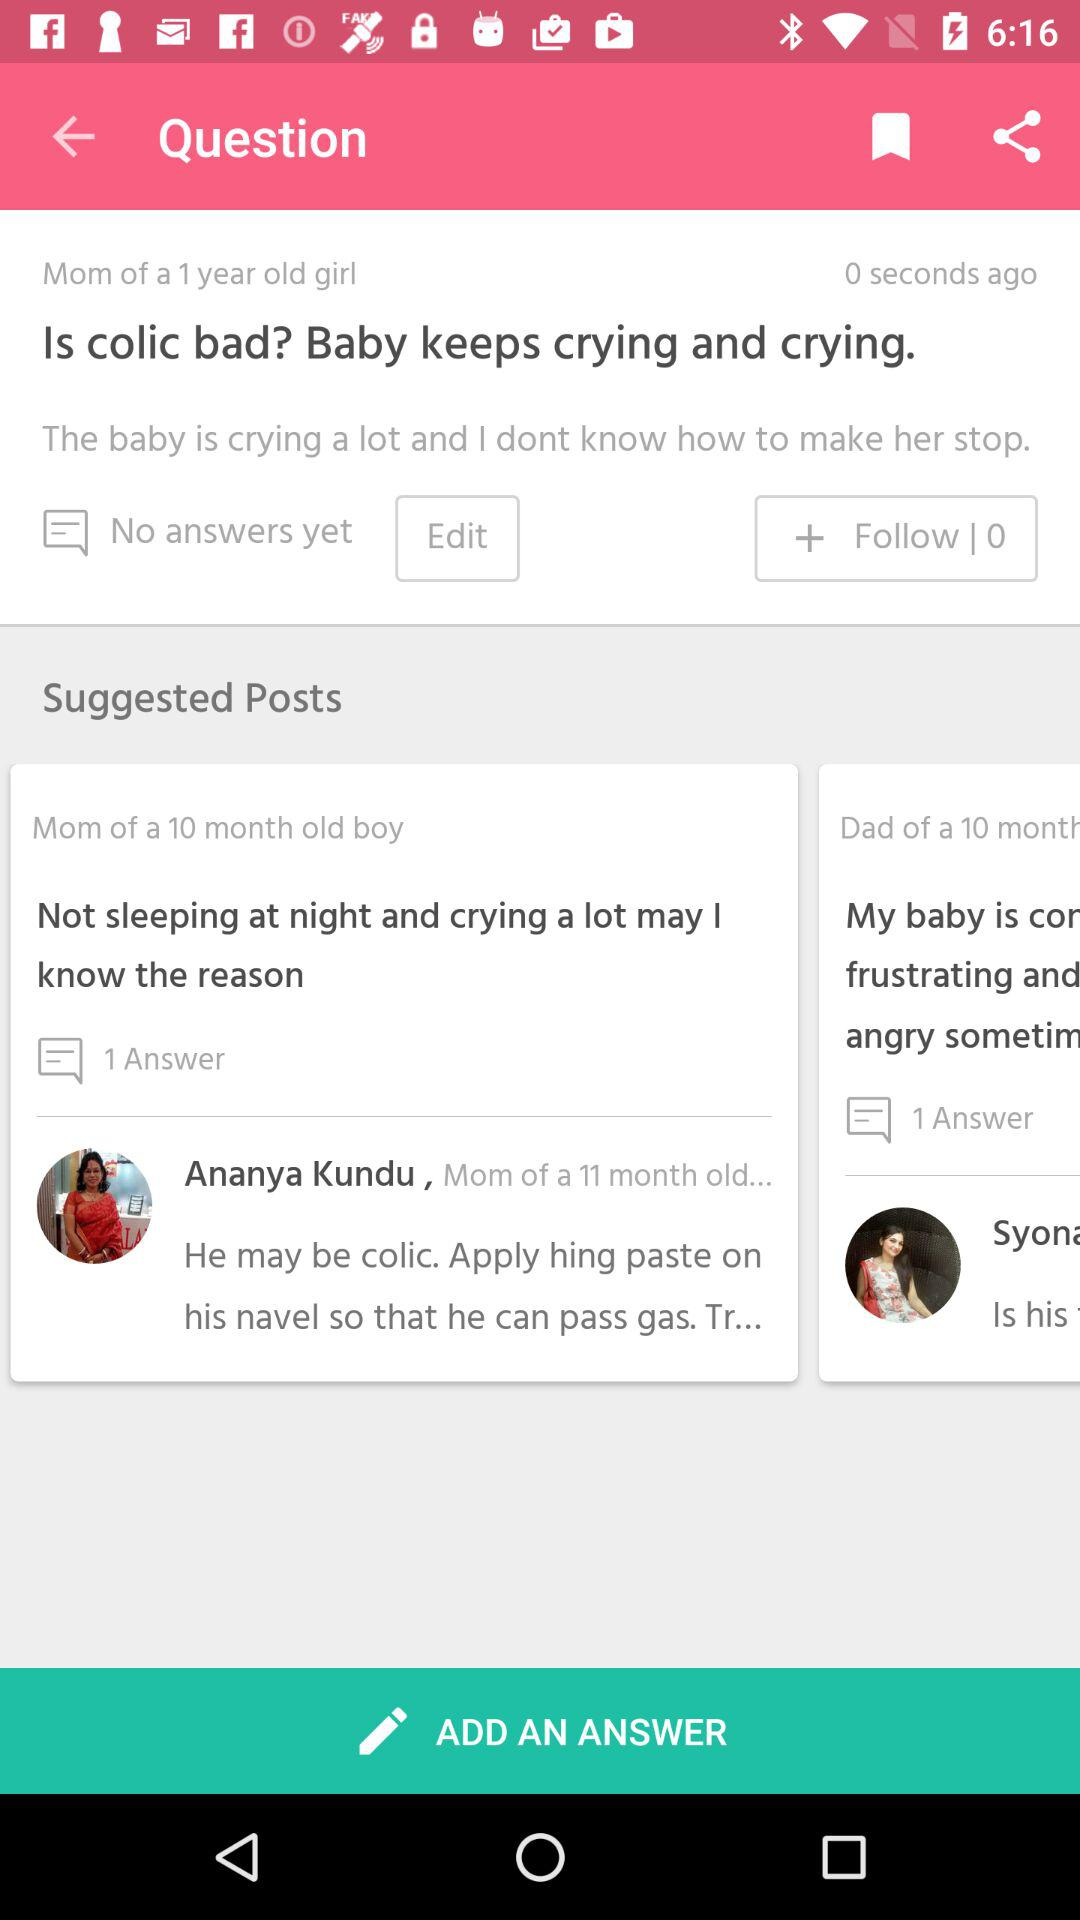How old is the boy? The boy is 10 months old. 